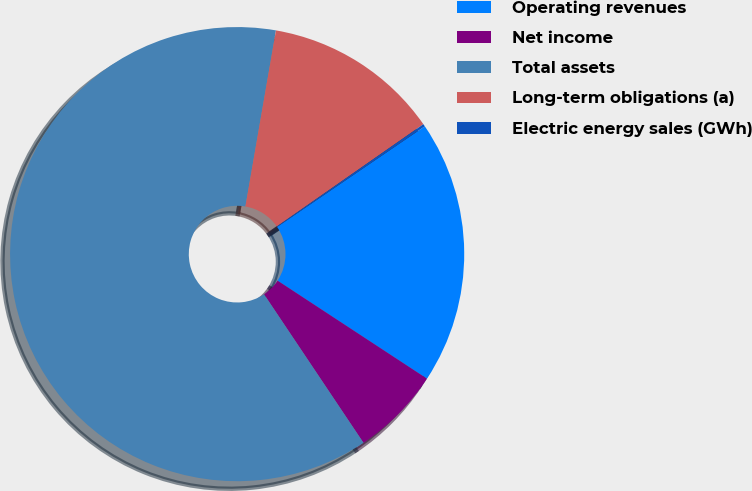Convert chart to OTSL. <chart><loc_0><loc_0><loc_500><loc_500><pie_chart><fcel>Operating revenues<fcel>Net income<fcel>Total assets<fcel>Long-term obligations (a)<fcel>Electric energy sales (GWh)<nl><fcel>18.76%<fcel>6.37%<fcel>62.13%<fcel>12.57%<fcel>0.18%<nl></chart> 